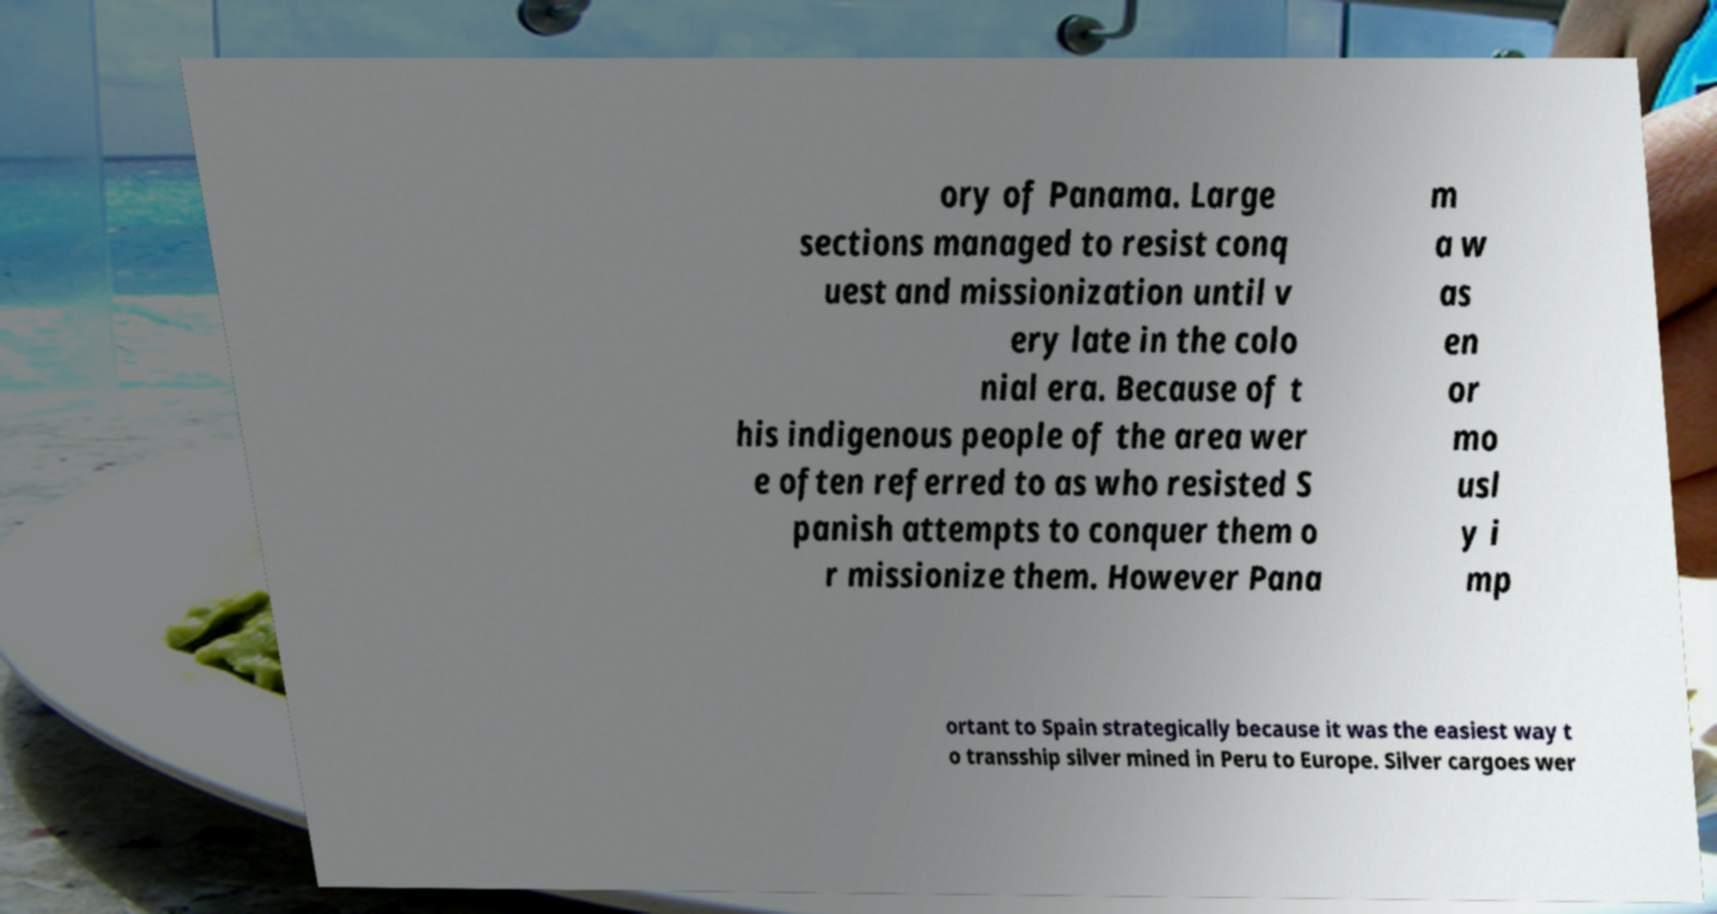Please read and relay the text visible in this image. What does it say? ory of Panama. Large sections managed to resist conq uest and missionization until v ery late in the colo nial era. Because of t his indigenous people of the area wer e often referred to as who resisted S panish attempts to conquer them o r missionize them. However Pana m a w as en or mo usl y i mp ortant to Spain strategically because it was the easiest way t o transship silver mined in Peru to Europe. Silver cargoes wer 